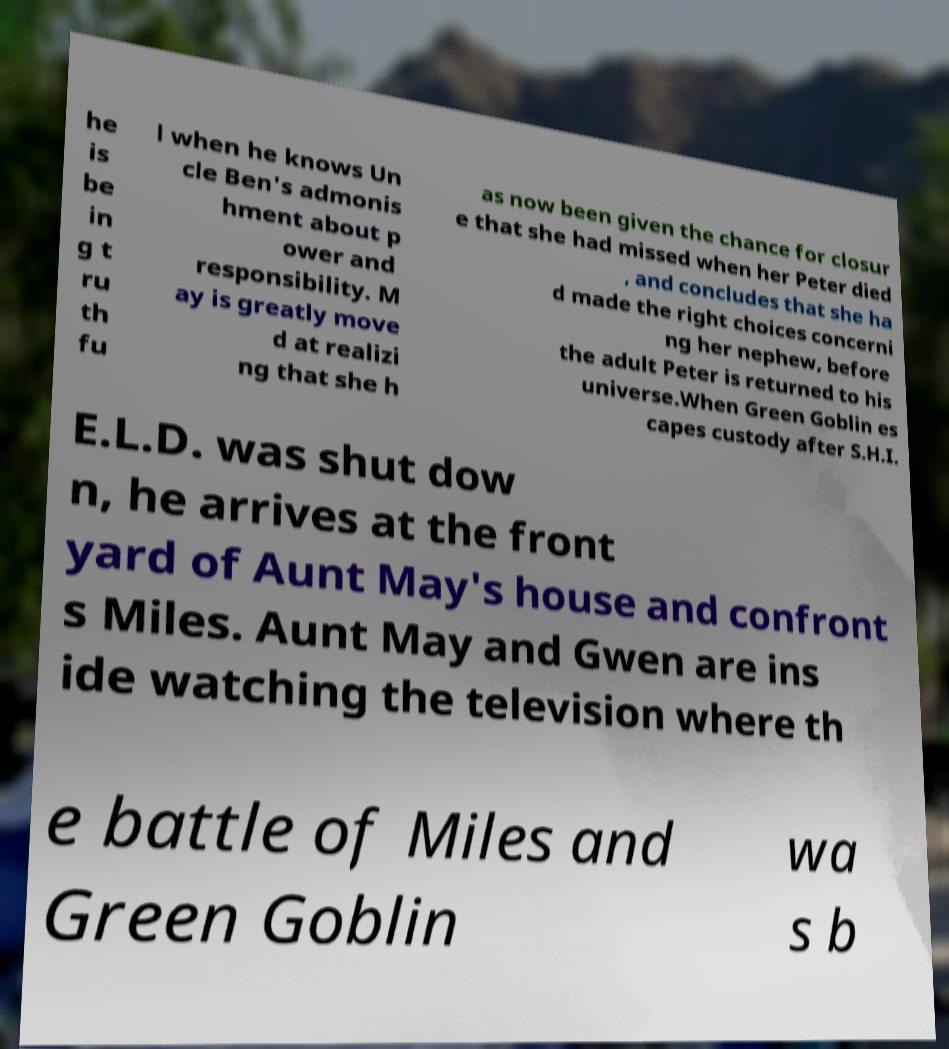There's text embedded in this image that I need extracted. Can you transcribe it verbatim? he is be in g t ru th fu l when he knows Un cle Ben's admonis hment about p ower and responsibility. M ay is greatly move d at realizi ng that she h as now been given the chance for closur e that she had missed when her Peter died , and concludes that she ha d made the right choices concerni ng her nephew, before the adult Peter is returned to his universe.When Green Goblin es capes custody after S.H.I. E.L.D. was shut dow n, he arrives at the front yard of Aunt May's house and confront s Miles. Aunt May and Gwen are ins ide watching the television where th e battle of Miles and Green Goblin wa s b 